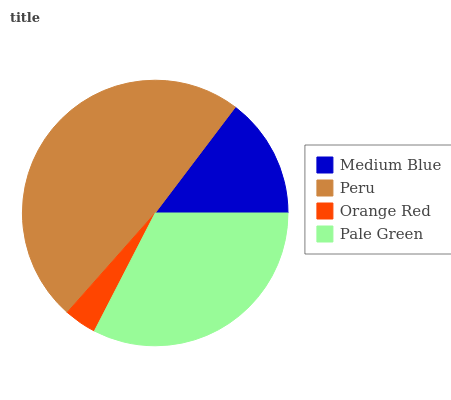Is Orange Red the minimum?
Answer yes or no. Yes. Is Peru the maximum?
Answer yes or no. Yes. Is Peru the minimum?
Answer yes or no. No. Is Orange Red the maximum?
Answer yes or no. No. Is Peru greater than Orange Red?
Answer yes or no. Yes. Is Orange Red less than Peru?
Answer yes or no. Yes. Is Orange Red greater than Peru?
Answer yes or no. No. Is Peru less than Orange Red?
Answer yes or no. No. Is Pale Green the high median?
Answer yes or no. Yes. Is Medium Blue the low median?
Answer yes or no. Yes. Is Orange Red the high median?
Answer yes or no. No. Is Orange Red the low median?
Answer yes or no. No. 